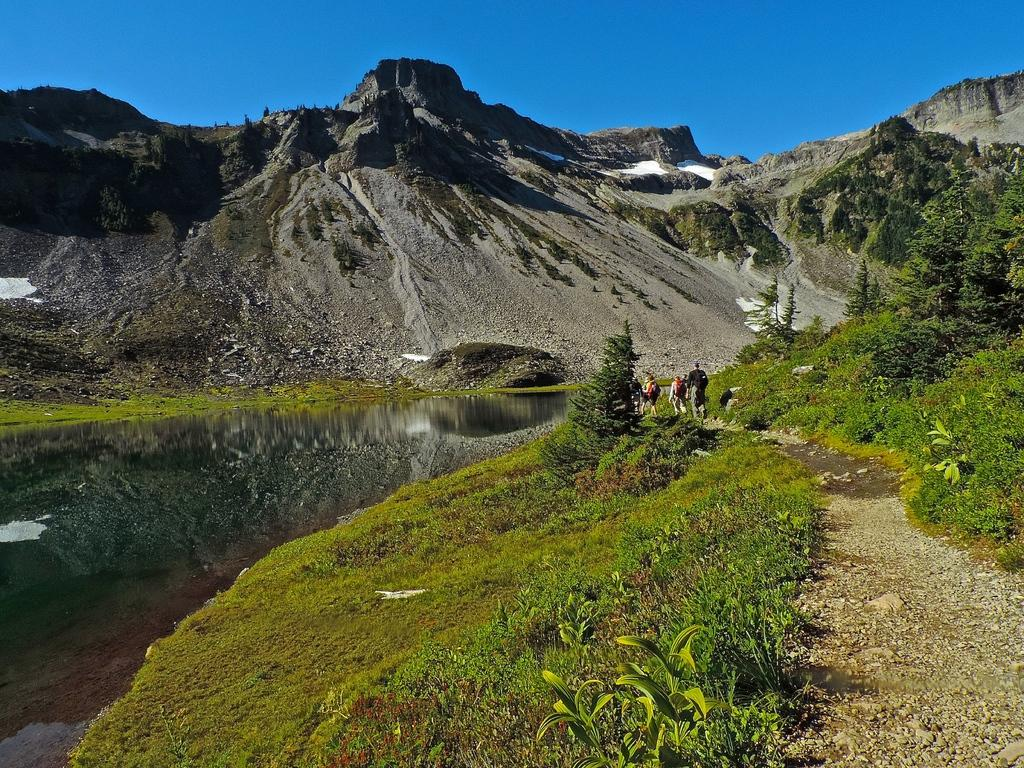What are the people in the image doing? The people in the image are walking. What type of terrain can be seen in the image? There are hills visible in the image. What type of vegetation is present in the image? There are plants and grass in the image. What type of ground surface is visible in the image? There is sand in the image. What is visible in the sky in the image? The sky is visible in the image. What type of plate is being used by the people in the image? There is no plate present in the image; the people are walking. Can you tell me how many accounts the people in the image have? There is no information about the people's accounts in the image. 